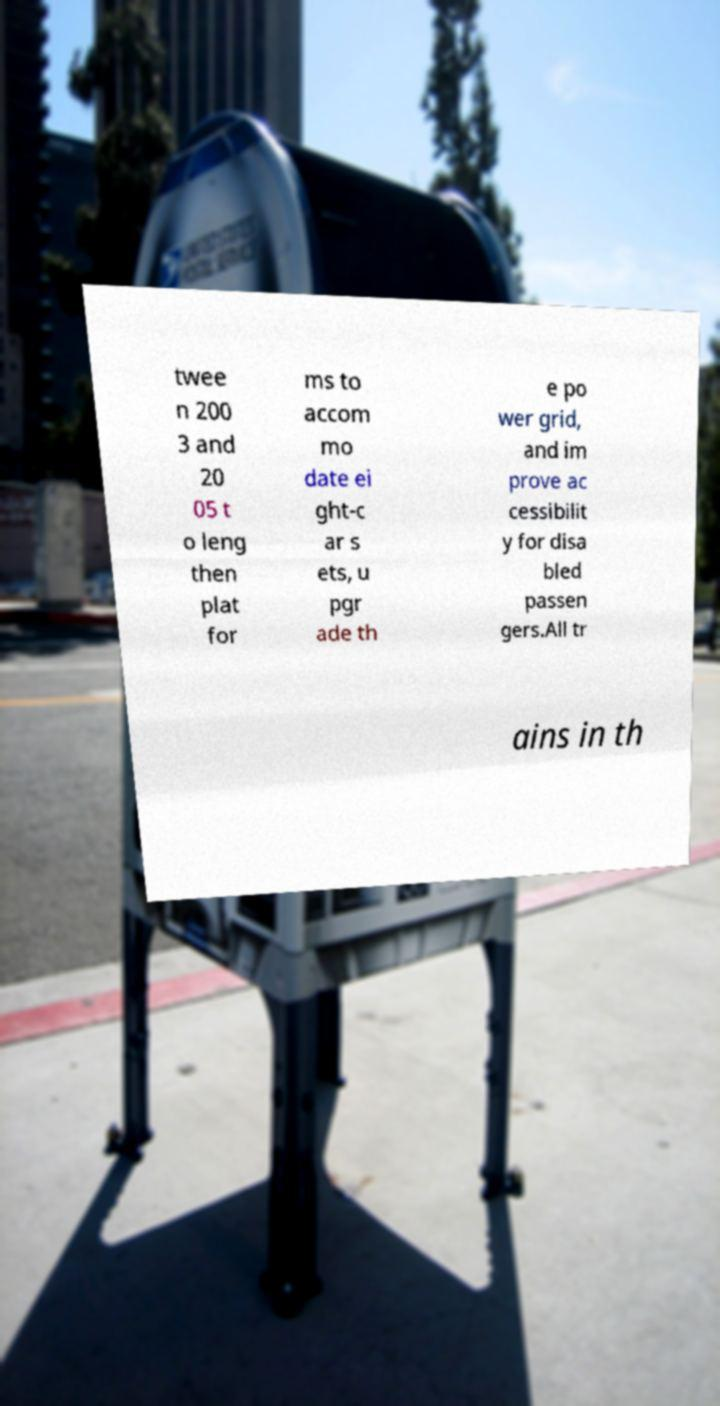I need the written content from this picture converted into text. Can you do that? twee n 200 3 and 20 05 t o leng then plat for ms to accom mo date ei ght-c ar s ets, u pgr ade th e po wer grid, and im prove ac cessibilit y for disa bled passen gers.All tr ains in th 